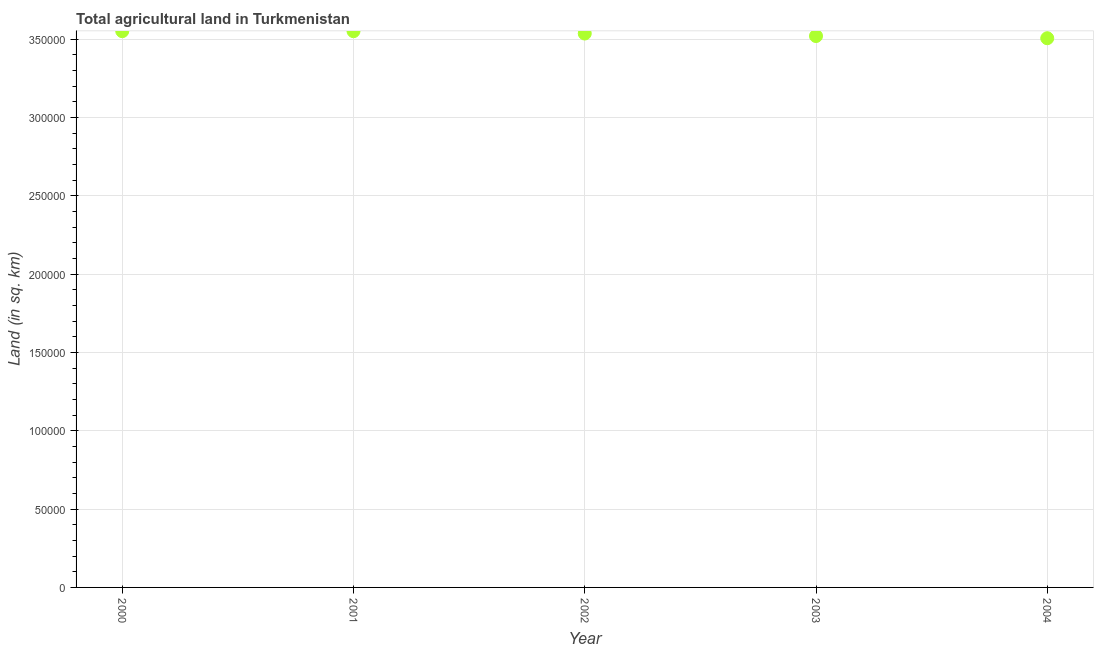What is the agricultural land in 2004?
Provide a short and direct response. 3.50e+05. Across all years, what is the maximum agricultural land?
Ensure brevity in your answer.  3.55e+05. Across all years, what is the minimum agricultural land?
Your answer should be very brief. 3.50e+05. In which year was the agricultural land minimum?
Make the answer very short. 2004. What is the sum of the agricultural land?
Offer a very short reply. 1.77e+06. What is the difference between the agricultural land in 2000 and 2001?
Ensure brevity in your answer.  0. What is the average agricultural land per year?
Your answer should be very brief. 3.53e+05. What is the median agricultural land?
Offer a terse response. 3.54e+05. In how many years, is the agricultural land greater than 160000 sq. km?
Your response must be concise. 5. Do a majority of the years between 2001 and 2002 (inclusive) have agricultural land greater than 290000 sq. km?
Make the answer very short. Yes. What is the ratio of the agricultural land in 2001 to that in 2004?
Make the answer very short. 1.01. Is the difference between the agricultural land in 2000 and 2004 greater than the difference between any two years?
Offer a terse response. Yes. What is the difference between the highest and the second highest agricultural land?
Offer a terse response. 0. Is the sum of the agricultural land in 2002 and 2003 greater than the maximum agricultural land across all years?
Provide a succinct answer. Yes. What is the difference between the highest and the lowest agricultural land?
Provide a short and direct response. 4500. Does the agricultural land monotonically increase over the years?
Your answer should be compact. No. How many years are there in the graph?
Your answer should be compact. 5. Does the graph contain grids?
Your response must be concise. Yes. What is the title of the graph?
Give a very brief answer. Total agricultural land in Turkmenistan. What is the label or title of the X-axis?
Keep it short and to the point. Year. What is the label or title of the Y-axis?
Offer a terse response. Land (in sq. km). What is the Land (in sq. km) in 2000?
Offer a very short reply. 3.55e+05. What is the Land (in sq. km) in 2001?
Give a very brief answer. 3.55e+05. What is the Land (in sq. km) in 2002?
Make the answer very short. 3.54e+05. What is the Land (in sq. km) in 2003?
Your answer should be very brief. 3.52e+05. What is the Land (in sq. km) in 2004?
Your answer should be compact. 3.50e+05. What is the difference between the Land (in sq. km) in 2000 and 2001?
Ensure brevity in your answer.  0. What is the difference between the Land (in sq. km) in 2000 and 2002?
Offer a terse response. 1500. What is the difference between the Land (in sq. km) in 2000 and 2003?
Keep it short and to the point. 3100. What is the difference between the Land (in sq. km) in 2000 and 2004?
Give a very brief answer. 4500. What is the difference between the Land (in sq. km) in 2001 and 2002?
Your answer should be compact. 1500. What is the difference between the Land (in sq. km) in 2001 and 2003?
Provide a succinct answer. 3100. What is the difference between the Land (in sq. km) in 2001 and 2004?
Make the answer very short. 4500. What is the difference between the Land (in sq. km) in 2002 and 2003?
Make the answer very short. 1600. What is the difference between the Land (in sq. km) in 2002 and 2004?
Your answer should be very brief. 3000. What is the difference between the Land (in sq. km) in 2003 and 2004?
Make the answer very short. 1400. What is the ratio of the Land (in sq. km) in 2000 to that in 2001?
Your response must be concise. 1. What is the ratio of the Land (in sq. km) in 2000 to that in 2002?
Keep it short and to the point. 1. What is the ratio of the Land (in sq. km) in 2001 to that in 2002?
Make the answer very short. 1. What is the ratio of the Land (in sq. km) in 2001 to that in 2003?
Your answer should be very brief. 1.01. 